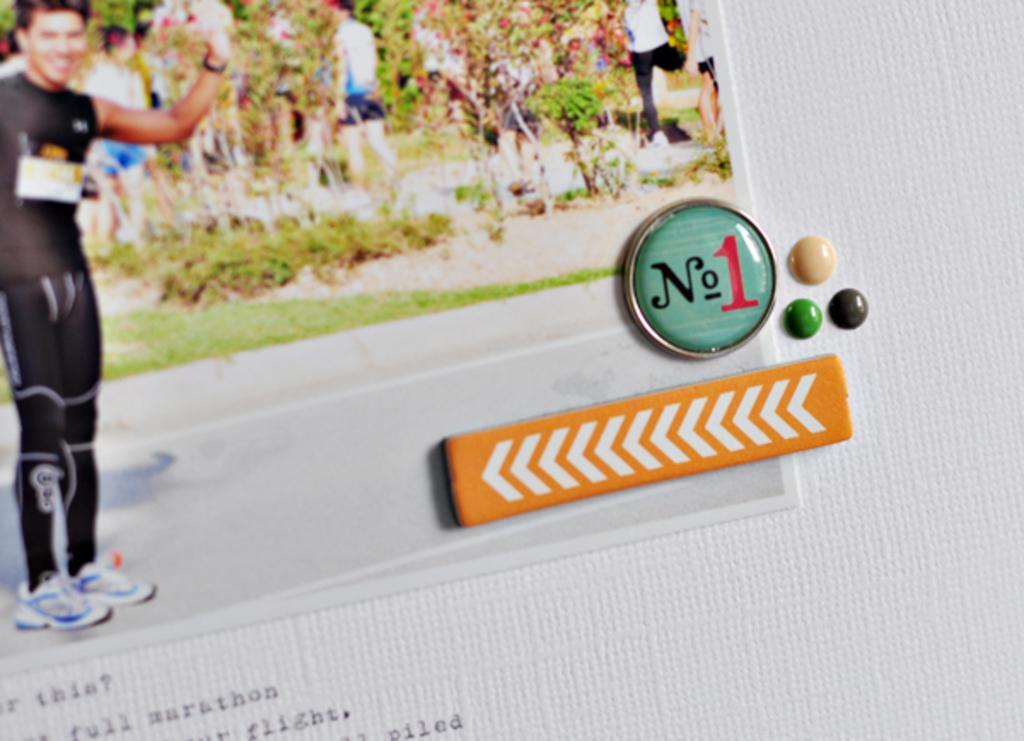Can you describe this image briefly? In this image I can see the photo and something is written on the white color surface. I can see the badge and few other objects can be seen. In the photo I can see few people and trees. 